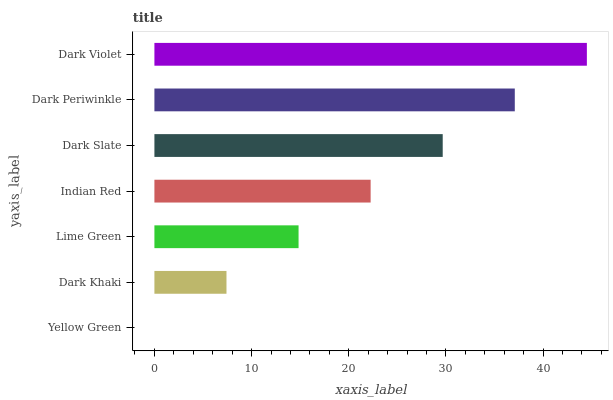Is Yellow Green the minimum?
Answer yes or no. Yes. Is Dark Violet the maximum?
Answer yes or no. Yes. Is Dark Khaki the minimum?
Answer yes or no. No. Is Dark Khaki the maximum?
Answer yes or no. No. Is Dark Khaki greater than Yellow Green?
Answer yes or no. Yes. Is Yellow Green less than Dark Khaki?
Answer yes or no. Yes. Is Yellow Green greater than Dark Khaki?
Answer yes or no. No. Is Dark Khaki less than Yellow Green?
Answer yes or no. No. Is Indian Red the high median?
Answer yes or no. Yes. Is Indian Red the low median?
Answer yes or no. Yes. Is Dark Khaki the high median?
Answer yes or no. No. Is Dark Khaki the low median?
Answer yes or no. No. 